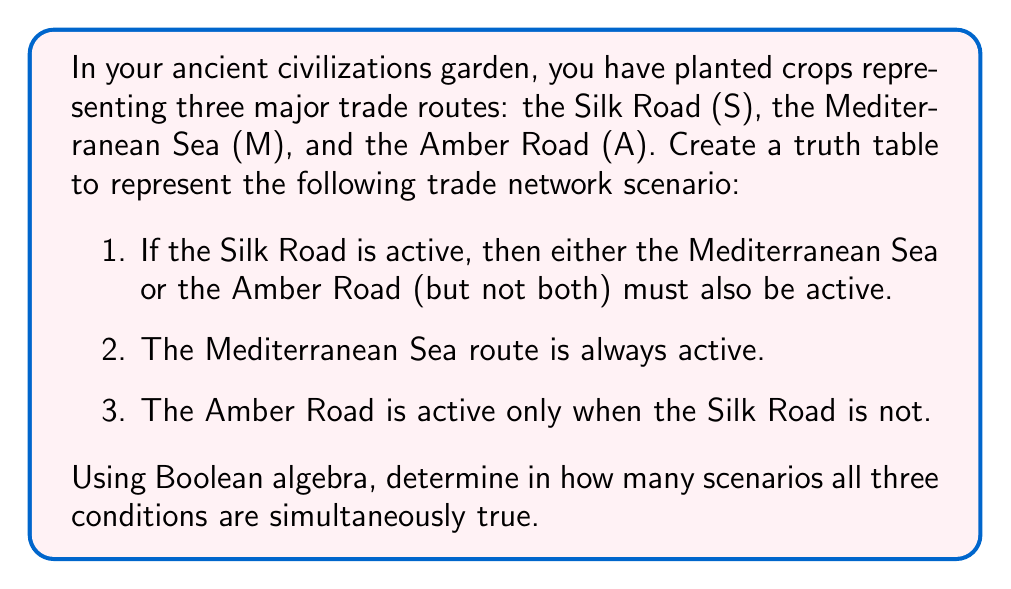Can you solve this math problem? Let's approach this step-by-step:

1) First, we need to create a truth table with all possible combinations of S, M, and A:

   S | M | A
   ---------
   0 | 0 | 0
   0 | 0 | 1
   0 | 1 | 0
   0 | 1 | 1
   1 | 0 | 0
   1 | 0 | 1
   1 | 1 | 0
   1 | 1 | 1

2) Now, let's apply each condition:

   Condition 1: $S \rightarrow (M \oplus A)$
   This can be written as: $\overline{S} \vee (M \oplus A)$

   Condition 2: M is always true (1)

   Condition 3: $A \leftrightarrow \overline{S}$

3) Let's evaluate each row:

   S | M | A | Cond1 | Cond2 | Cond3 | All True
   -------------------------------------------
   0 | 0 | 0 |   1   |   0   |   1   |    0
   0 | 0 | 1 |   1   |   0   |   1   |    0
   0 | 1 | 0 |   1   |   1   |   1   |    1
   0 | 1 | 1 |   1   |   1   |   0   |    0
   1 | 0 | 0 |   0   |   0   |   1   |    0
   1 | 0 | 1 |   1   |   0   |   0   |    0
   1 | 1 | 0 |   1   |   1   |   1   |    1
   1 | 1 | 1 |   0   |   1   |   0   |    0

4) Counting the rows where all conditions are true (1 in the "All True" column), we find that there are 2 scenarios where all conditions are simultaneously true.
Answer: 2 scenarios 